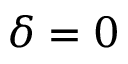Convert formula to latex. <formula><loc_0><loc_0><loc_500><loc_500>\delta = 0</formula> 